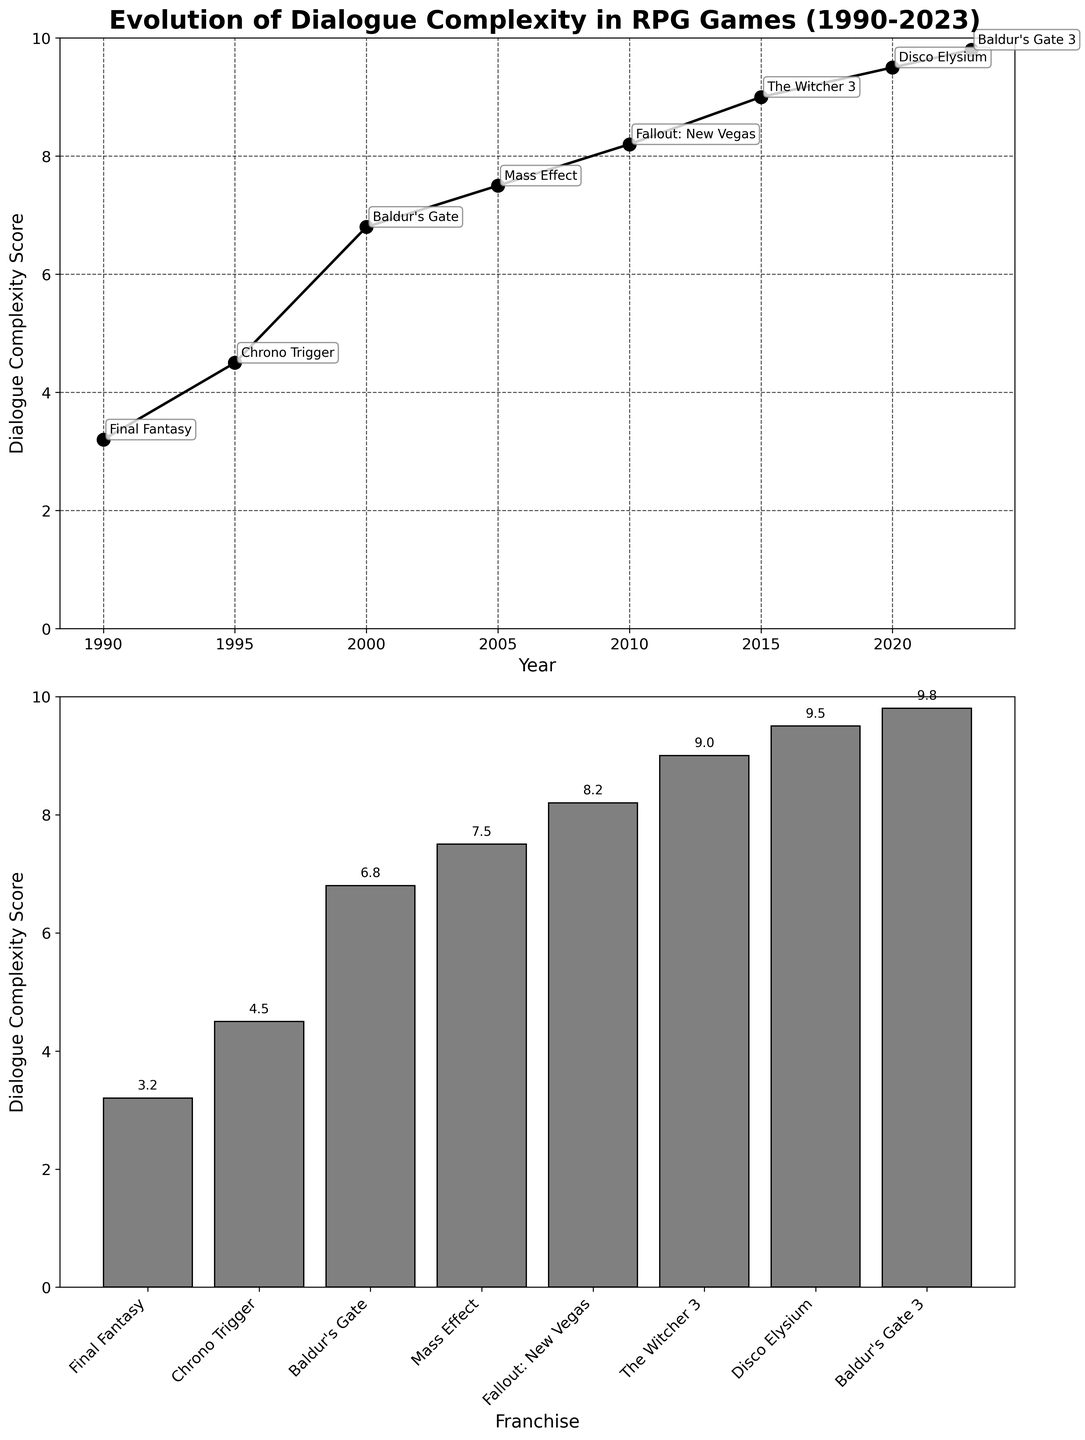What is the title of the figure? The title of the figure can be found at the top of the grid of subplots. It provides an overview of the data displayed.
Answer: Evolution of Dialogue Complexity in RPG Games (1990-2023) How many franchises are represented in the bar plot? Count the number of bars in the second subplot, where each bar represents a franchise.
Answer: 8 What year had the highest dialogue complexity score? Locate the highest point on the line plot in the first subplot and find the corresponding year on the x-axis.
Answer: 2023 Which franchise had the highest dialogue complexity score? Identify the tallest bar in the bar plot of the second subplot and read the corresponding franchise label.
Answer: Baldur's Gate 3 Which two years show the most significant increase in dialogue complexity score? Look at the line plot and identify the two years between which the steepest upward slope occurs.
Answer: 2015 to 2020 What is the dialogue complexity score for The Witcher 3? Refer to the bar plot and find the bar labeled "The Witcher 3" to read its height, indicating the score.
Answer: 9.0 Rank the franchises from highest to lowest dialogue complexity score. Compare the heights of the bars in the bar plot and list the franchises in descending order based on their scores.
Answer: Baldur's Gate 3, Disco Elysium, The Witcher 3, Fallout: New Vegas, Mass Effect, Baldur's Gate, Chrono Trigger, Final Fantasy How did the dialogue complexity score change from 1990 to 2023? Observe the trend in the line plot from the first year to the last year to determine the overall change.
Answer: It increased What notable feature corresponds with the 2005 data point? Refer to any annotations or labels near the 2005 data point in the line plot to find the notable feature listed.
Answer: Morality system affecting conversations By how much did the dialogue complexity score increase from the year Mass Effect (2005) to the year Disco Elysium (2020)? Subtract the score of Mass Effect from the score of Disco Elysium to find the difference.
Answer: 2.0 